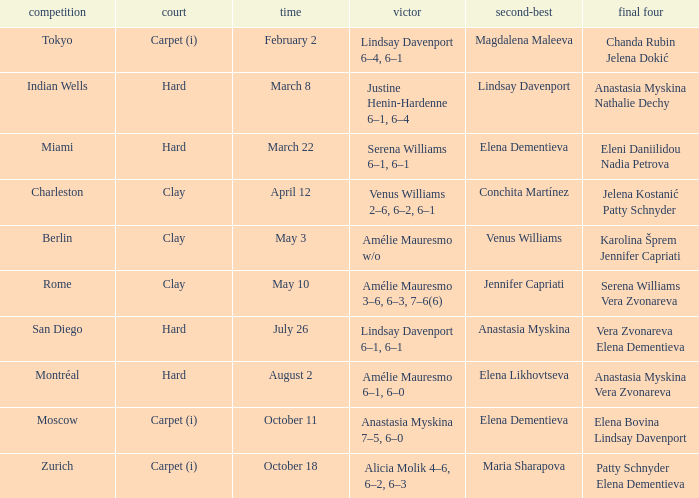Who were the semifinalists in the Rome tournament? Serena Williams Vera Zvonareva. 